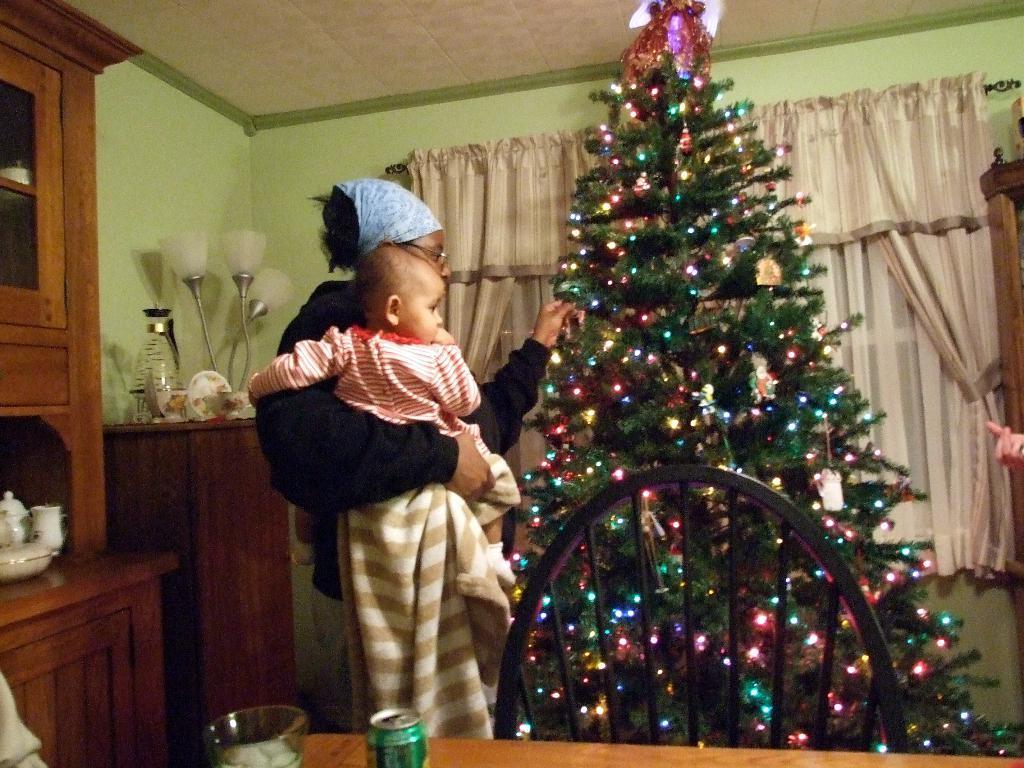How would you summarize this image in a sentence or two? This is an inside view of a room. On the right side, I can see a Christmas tree. Beside this a woman is standing, holding a baby in the hand and looking at the Christmas tree. At the bottom of the image there is a table on which I can see a cup and a bowl. Beside the table there is a chair. On the left side, I can see a cupboard and a table on which few objects are placed. In the background there is a wall along with the curtain which is hanging to a metal rod. 